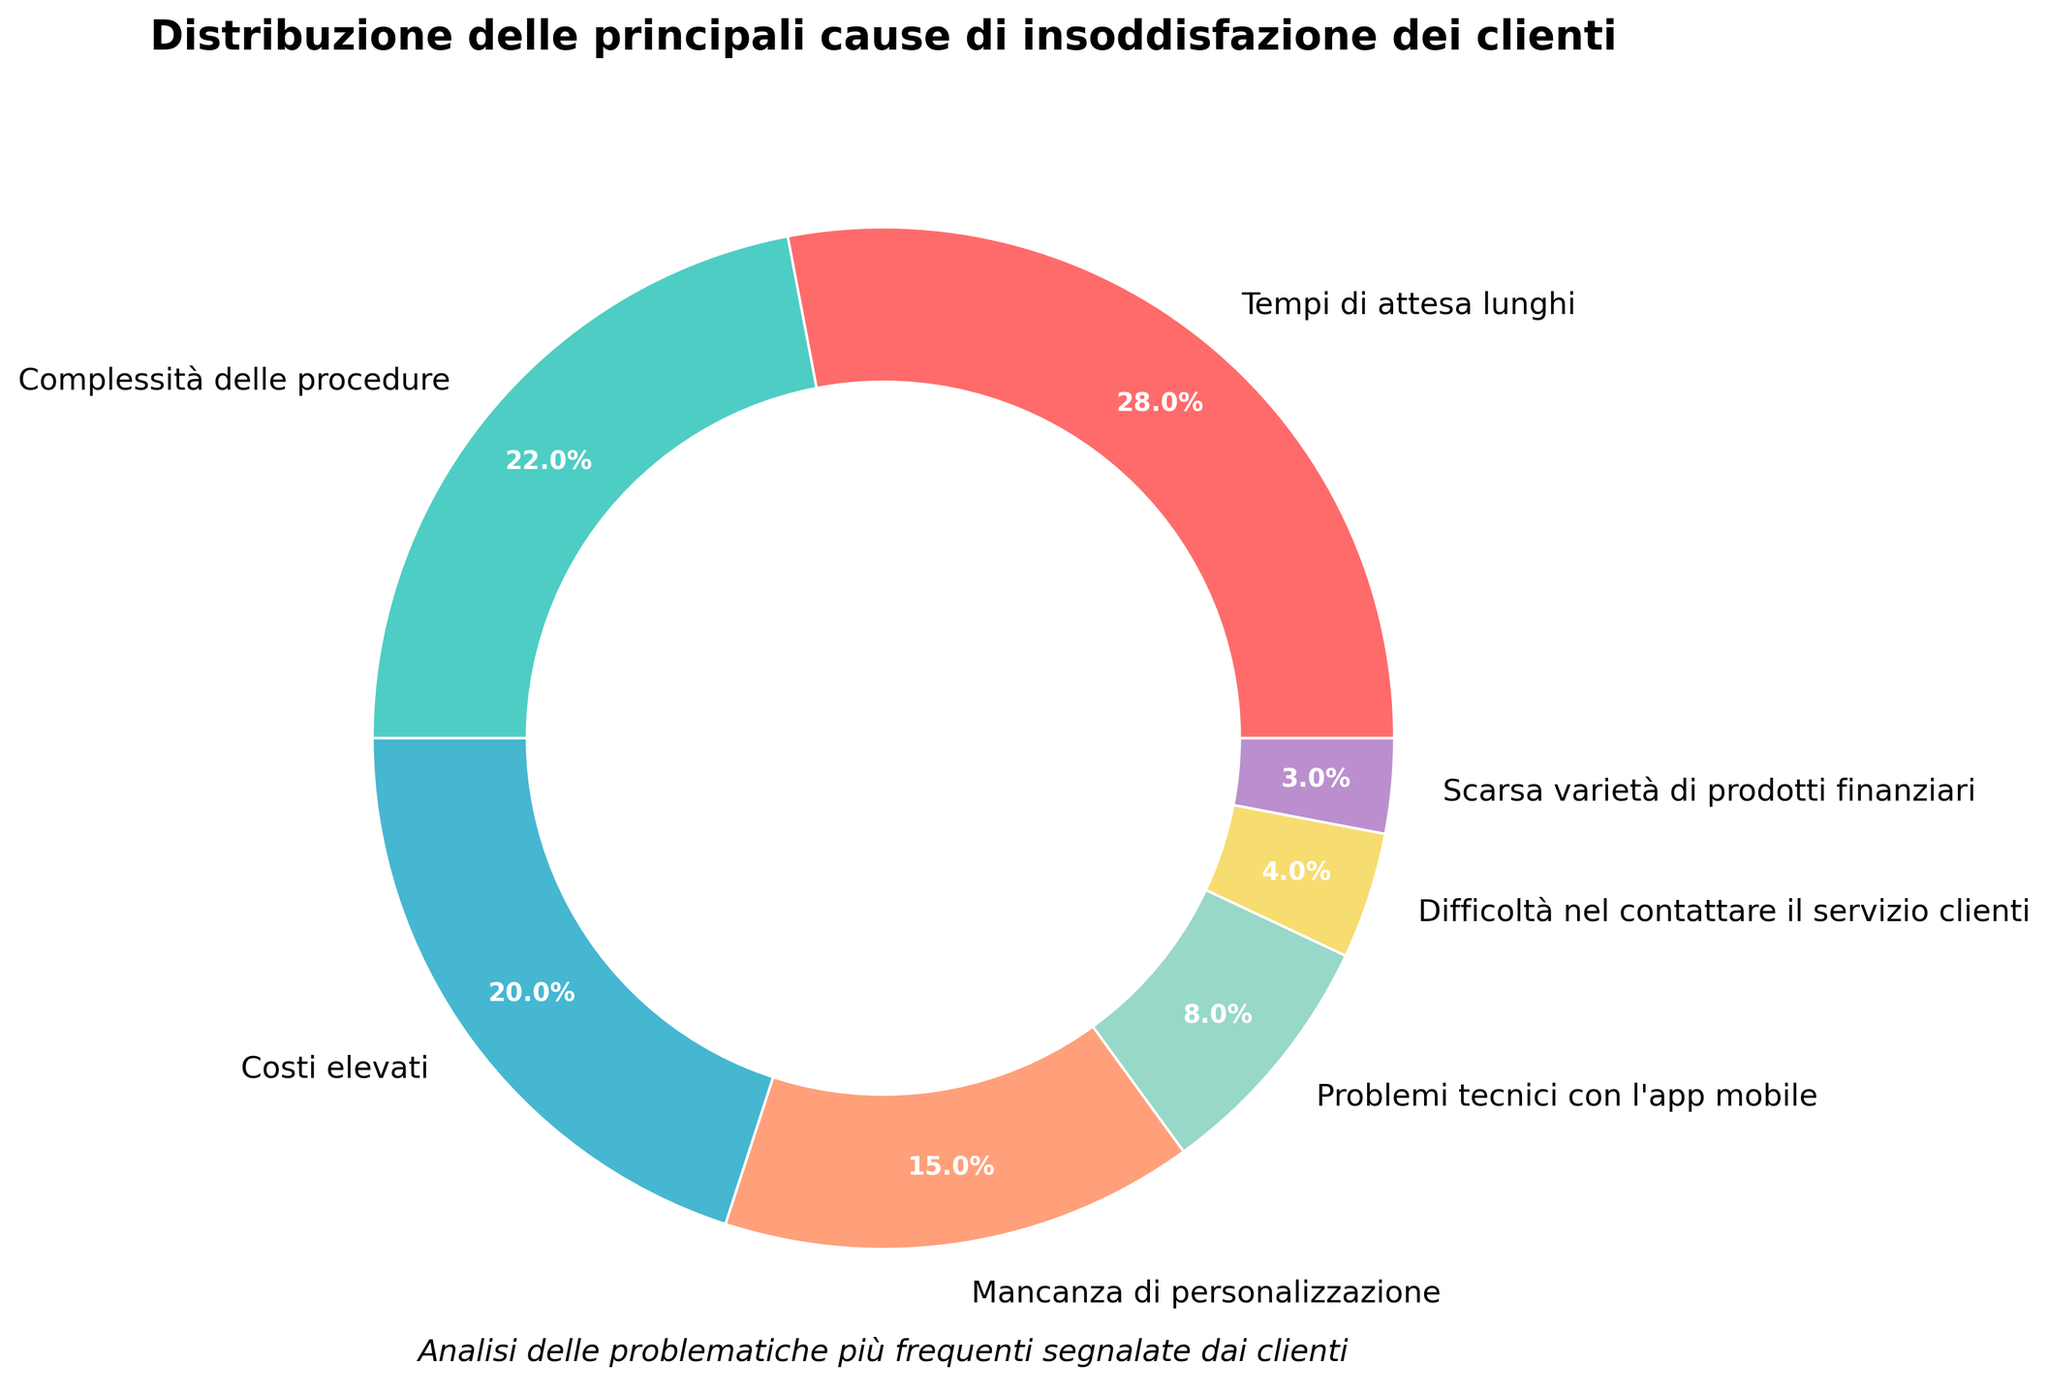Qual è la principale causa di insoddisfazione dei clienti? Osservando la dimensione delle sezioni sulla ciambella, vediamo che la sezione più grande rappresenta i "Tempi di attesa lunghi" con il 28%, quindi questa è la principale causa di insoddisfazione.
Answer: Tempi di attesa lunghi Qual è la differenza in percentuale tra i "Tempi di attesa lunghi" e la "Complessità delle procedure"? Dalla ciambella, vediamo che i "Tempi di attesa lunghi" rappresentano il 28% e la "Complessità delle procedure" il 22%. La differenza quindi è 28% - 22% = 6%.
Answer: 6% Quali sono le due cause minori di insoddisfazione e qual è la loro percentuale combinata? Guardando la ciambella, le sezioni più piccole sono "Difficoltà nel contattare il servizio clienti" (4%) e "Scarsa varietà di prodotti finanziari" (3%). La percentuale combinata è 4% + 3% = 7%.
Answer: 7% Quanto sono maggiori i "Costi elevati" rispetto ai "Problemi tecnici con l'app mobile"? "Costi elevati" rappresentano il 20% mentre "Problemi tecnici con l'app mobile" rappresentano l'8%. La differenza è 20% - 8% = 12%.
Answer: 12% Quali due cause hanno un'incidenza combinata di almeno il 40%? Osservando la ciambella, vediamo che le due maggiori sezioni sono "Tempi di attesa lunghi" (28%) e "Complessità delle procedure" (22%). La loro incidenza combinata è 28% + 22% = 50%, che è superiore al 40%.
Answer: Tempi di attesa lunghi e Complessità delle procedure Quale colore rappresenta la "Mancanza di personalizzazione" e quale percentuale copre? La sezione colorata di verde rappresenta la "Mancanza di personalizzazione" con una percentuale del 15%.
Answer: Verde, 15% Se combinassimo le percentuali di "Difficoltà nel contattare il servizio clienti" e "Scarsa varietà di prodotti finanziari", supererebbe la "Mancanza di personalizzazione"? La "Mancanza di personalizzazione" rappresenta il 15%. Combinando "Difficoltà nel contattare il servizio clienti" (4%) e "Scarsa varietà di prodotti finanziari" (3%), otteniamo 4% + 3% = 7%, che è inferiore al 15%.
Answer: No Quale causa ha più del doppio di incidenza rispetto ai "Problemi tecnici con l'app mobile"? I "Problemi tecnici con l'app mobile" rappresentano l'8%. Le cause con un'incidenza più che doppia sono "Tempi di attesa lunghi" (28%) e "Complessità delle procedure" (22%).
Answer: Tempi di attesa lunghi, Complessità delle procedure 